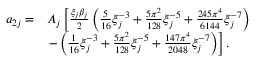<formula> <loc_0><loc_0><loc_500><loc_500>\begin{array} { r l } { a _ { 2 j } = } & { A _ { j } \left [ \frac { \xi _ { j } \beta _ { j } } { 2 } \left ( \frac { 5 } { 1 6 } \xi _ { j } ^ { - 3 } + \frac { 5 \pi ^ { 2 } } { 1 2 8 } \xi _ { j } ^ { - 5 } + \frac { 2 4 5 \pi ^ { 4 } } { 6 1 4 4 } \xi _ { j } ^ { - 7 } \right ) } \\ & { - \left ( \frac { 1 } { 1 6 } \xi _ { j } ^ { - 3 } + \frac { 5 \pi ^ { 2 } } { 1 2 8 } \xi _ { j } ^ { - 5 } + \frac { 1 4 7 \pi ^ { 4 } } { 2 0 4 8 } \xi _ { j } ^ { - 7 } \right ) \right ] . } \end{array}</formula> 